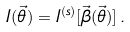<formula> <loc_0><loc_0><loc_500><loc_500>I ( \vec { \theta } ) = I ^ { ( s ) } [ \vec { \beta } ( \vec { \theta } ) ] \, .</formula> 